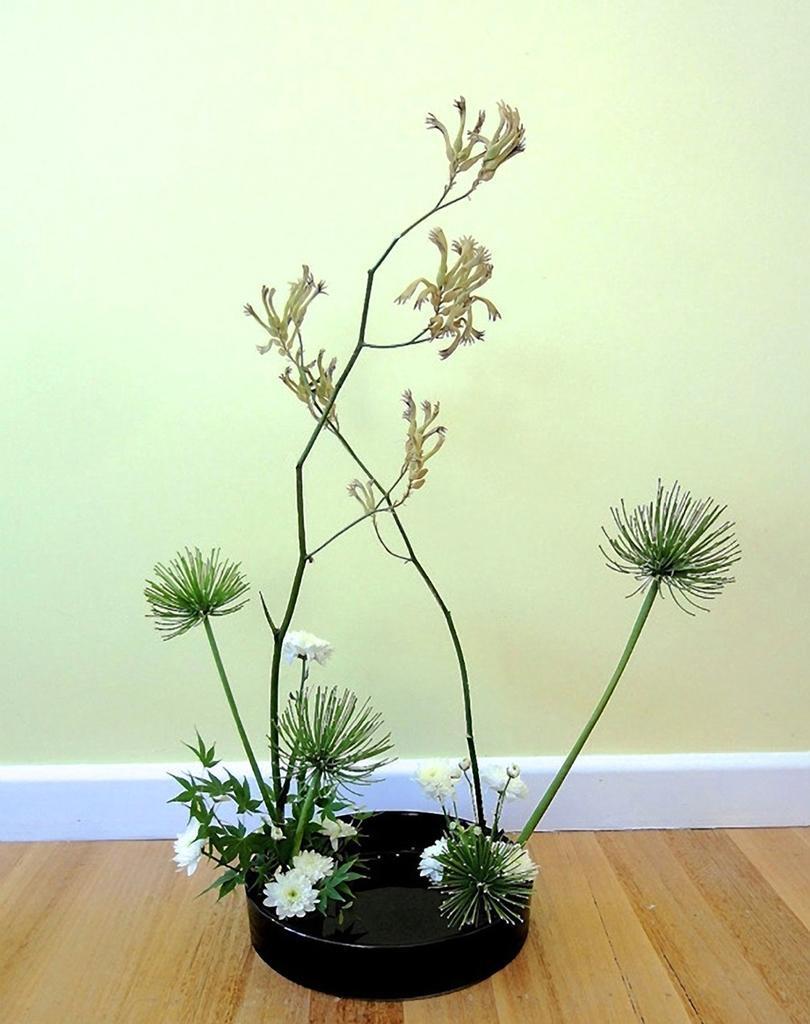How would you summarize this image in a sentence or two? In this picture we can see a decorative plant on a black object and the black object is on the wooden floor. Behind the plant where is the wall. 